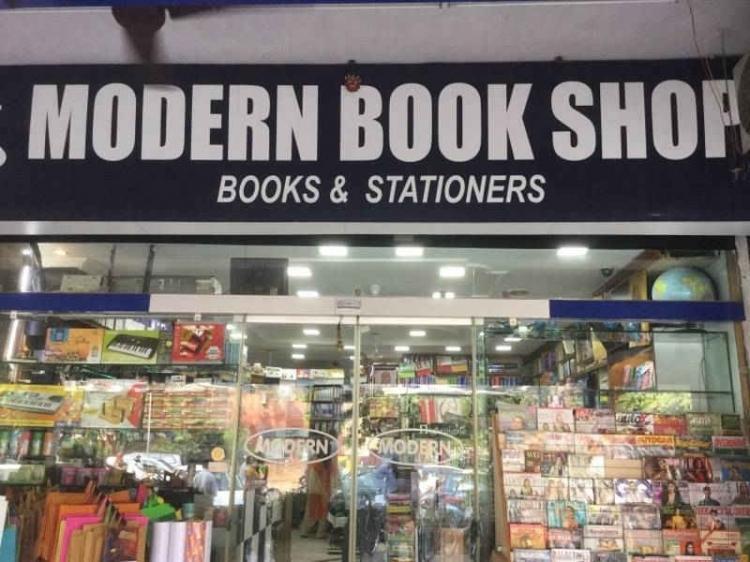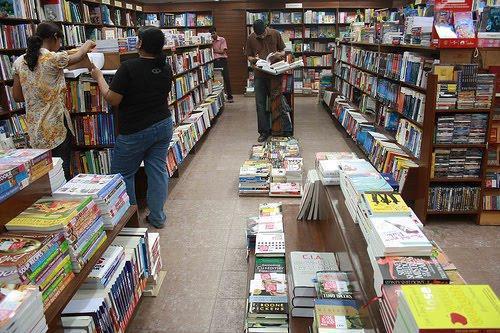The first image is the image on the left, the second image is the image on the right. For the images shown, is this caption "The image to the left appears to feature an open air shop; no windows seem to bar the store from the elements." true? Answer yes or no. No. 